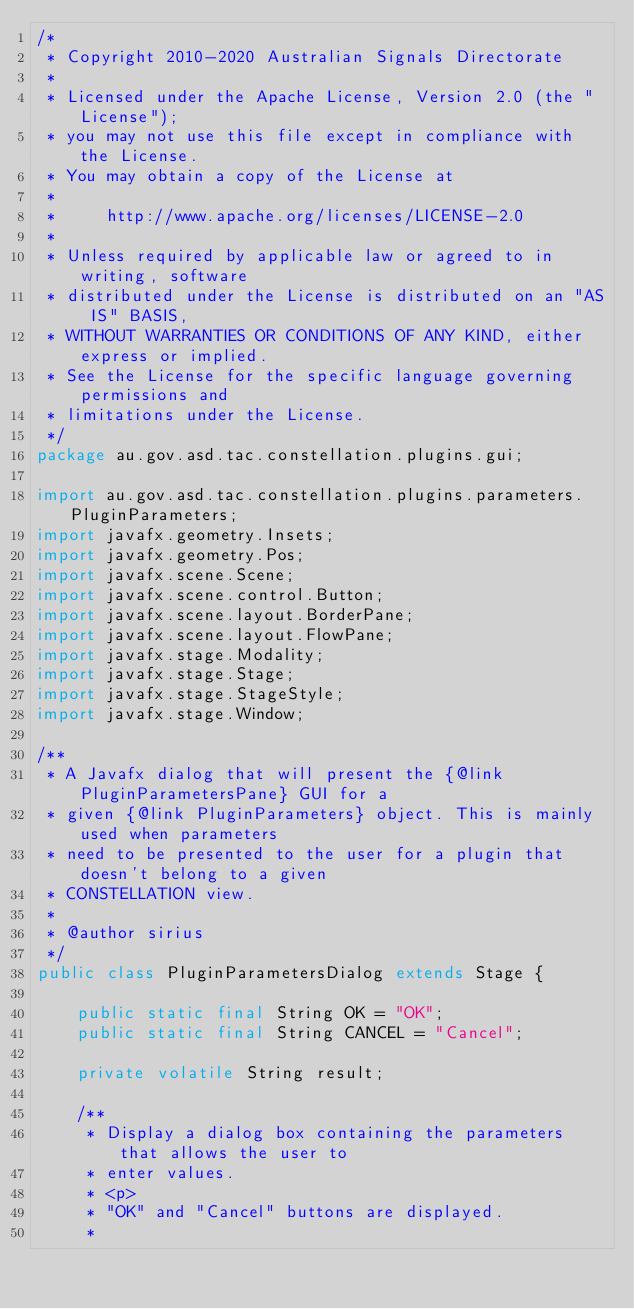Convert code to text. <code><loc_0><loc_0><loc_500><loc_500><_Java_>/*
 * Copyright 2010-2020 Australian Signals Directorate
 *
 * Licensed under the Apache License, Version 2.0 (the "License");
 * you may not use this file except in compliance with the License.
 * You may obtain a copy of the License at
 *
 *     http://www.apache.org/licenses/LICENSE-2.0
 *
 * Unless required by applicable law or agreed to in writing, software
 * distributed under the License is distributed on an "AS IS" BASIS,
 * WITHOUT WARRANTIES OR CONDITIONS OF ANY KIND, either express or implied.
 * See the License for the specific language governing permissions and
 * limitations under the License.
 */
package au.gov.asd.tac.constellation.plugins.gui;

import au.gov.asd.tac.constellation.plugins.parameters.PluginParameters;
import javafx.geometry.Insets;
import javafx.geometry.Pos;
import javafx.scene.Scene;
import javafx.scene.control.Button;
import javafx.scene.layout.BorderPane;
import javafx.scene.layout.FlowPane;
import javafx.stage.Modality;
import javafx.stage.Stage;
import javafx.stage.StageStyle;
import javafx.stage.Window;

/**
 * A Javafx dialog that will present the {@link PluginParametersPane} GUI for a
 * given {@link PluginParameters} object. This is mainly used when parameters
 * need to be presented to the user for a plugin that doesn't belong to a given
 * CONSTELLATION view.
 *
 * @author sirius
 */
public class PluginParametersDialog extends Stage {

    public static final String OK = "OK";
    public static final String CANCEL = "Cancel";

    private volatile String result;

    /**
     * Display a dialog box containing the parameters that allows the user to
     * enter values.
     * <p>
     * "OK" and "Cancel" buttons are displayed.
     *</code> 